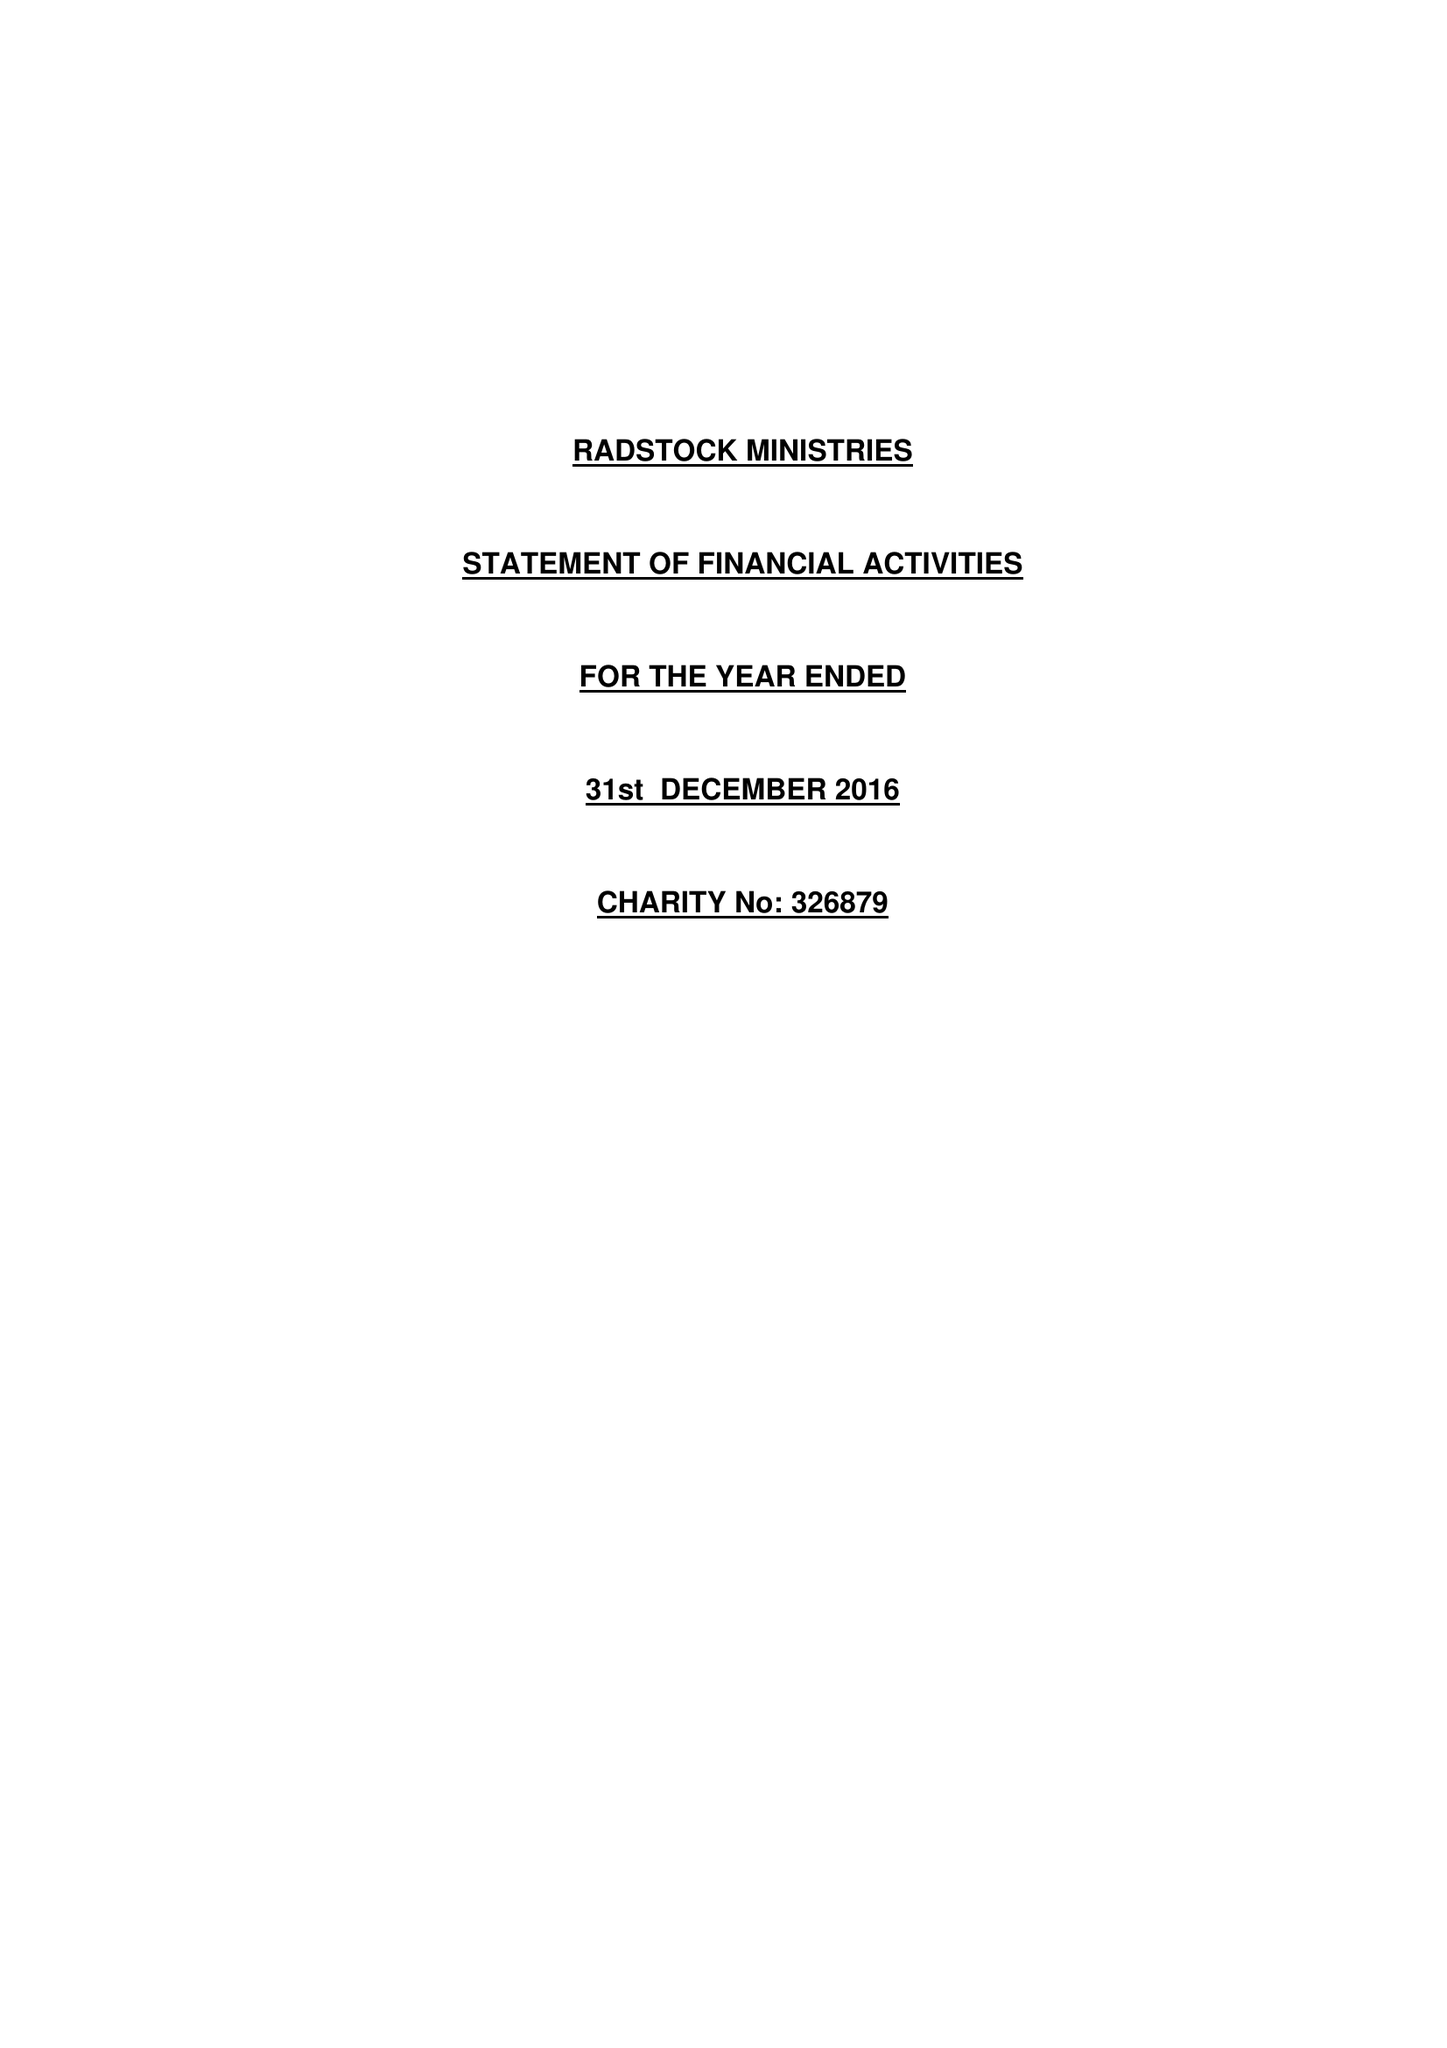What is the value for the spending_annually_in_british_pounds?
Answer the question using a single word or phrase. 182816.00 